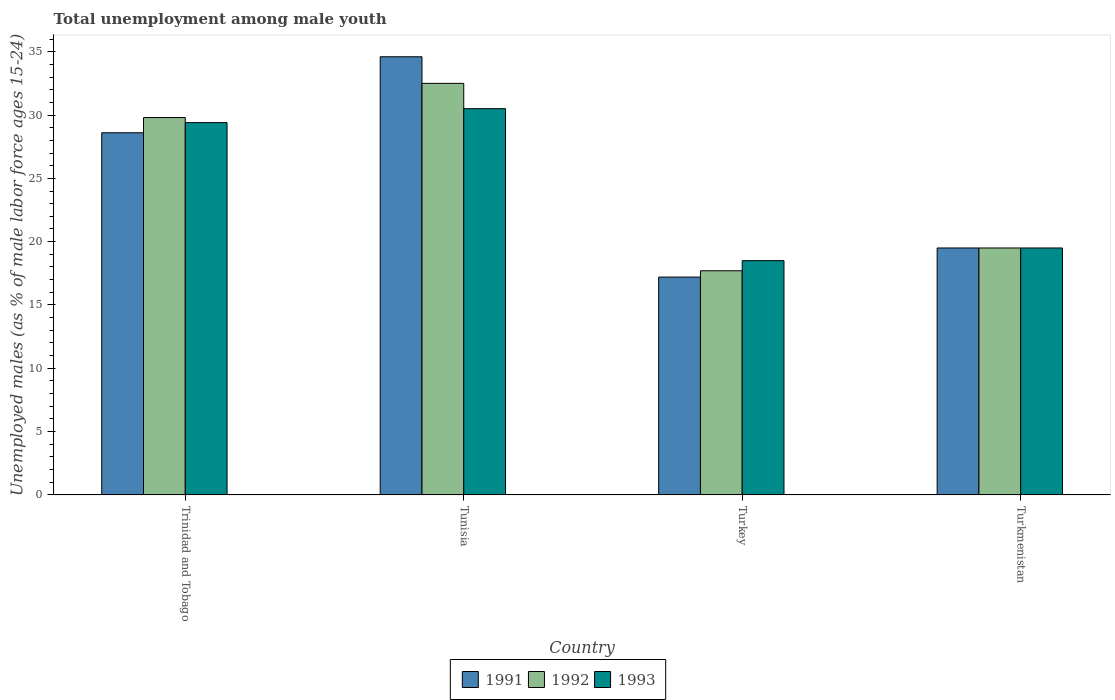How many different coloured bars are there?
Your answer should be very brief. 3. How many groups of bars are there?
Provide a short and direct response. 4. What is the label of the 2nd group of bars from the left?
Your answer should be compact. Tunisia. In how many cases, is the number of bars for a given country not equal to the number of legend labels?
Provide a short and direct response. 0. What is the percentage of unemployed males in in 1991 in Tunisia?
Provide a short and direct response. 34.6. Across all countries, what is the maximum percentage of unemployed males in in 1992?
Your response must be concise. 32.5. Across all countries, what is the minimum percentage of unemployed males in in 1992?
Your answer should be compact. 17.7. In which country was the percentage of unemployed males in in 1991 maximum?
Make the answer very short. Tunisia. In which country was the percentage of unemployed males in in 1993 minimum?
Make the answer very short. Turkey. What is the total percentage of unemployed males in in 1993 in the graph?
Your response must be concise. 97.9. What is the difference between the percentage of unemployed males in in 1993 in Trinidad and Tobago and that in Turkmenistan?
Offer a terse response. 9.9. What is the difference between the percentage of unemployed males in in 1991 in Turkmenistan and the percentage of unemployed males in in 1992 in Trinidad and Tobago?
Ensure brevity in your answer.  -10.3. What is the average percentage of unemployed males in in 1993 per country?
Your answer should be very brief. 24.47. What is the difference between the percentage of unemployed males in of/in 1991 and percentage of unemployed males in of/in 1992 in Tunisia?
Your answer should be compact. 2.1. What is the ratio of the percentage of unemployed males in in 1992 in Turkey to that in Turkmenistan?
Give a very brief answer. 0.91. Is the percentage of unemployed males in in 1991 in Turkey less than that in Turkmenistan?
Keep it short and to the point. Yes. What is the difference between the highest and the lowest percentage of unemployed males in in 1993?
Ensure brevity in your answer.  12. Is the sum of the percentage of unemployed males in in 1991 in Trinidad and Tobago and Turkey greater than the maximum percentage of unemployed males in in 1992 across all countries?
Provide a short and direct response. Yes. Is it the case that in every country, the sum of the percentage of unemployed males in in 1993 and percentage of unemployed males in in 1991 is greater than the percentage of unemployed males in in 1992?
Provide a succinct answer. Yes. How many bars are there?
Offer a very short reply. 12. How many countries are there in the graph?
Offer a terse response. 4. What is the difference between two consecutive major ticks on the Y-axis?
Offer a terse response. 5. Does the graph contain any zero values?
Ensure brevity in your answer.  No. What is the title of the graph?
Offer a very short reply. Total unemployment among male youth. Does "1983" appear as one of the legend labels in the graph?
Make the answer very short. No. What is the label or title of the Y-axis?
Keep it short and to the point. Unemployed males (as % of male labor force ages 15-24). What is the Unemployed males (as % of male labor force ages 15-24) in 1991 in Trinidad and Tobago?
Provide a succinct answer. 28.6. What is the Unemployed males (as % of male labor force ages 15-24) of 1992 in Trinidad and Tobago?
Provide a short and direct response. 29.8. What is the Unemployed males (as % of male labor force ages 15-24) of 1993 in Trinidad and Tobago?
Make the answer very short. 29.4. What is the Unemployed males (as % of male labor force ages 15-24) in 1991 in Tunisia?
Provide a succinct answer. 34.6. What is the Unemployed males (as % of male labor force ages 15-24) in 1992 in Tunisia?
Provide a short and direct response. 32.5. What is the Unemployed males (as % of male labor force ages 15-24) in 1993 in Tunisia?
Make the answer very short. 30.5. What is the Unemployed males (as % of male labor force ages 15-24) in 1991 in Turkey?
Keep it short and to the point. 17.2. What is the Unemployed males (as % of male labor force ages 15-24) in 1992 in Turkey?
Make the answer very short. 17.7. What is the Unemployed males (as % of male labor force ages 15-24) of 1993 in Turkey?
Keep it short and to the point. 18.5. What is the Unemployed males (as % of male labor force ages 15-24) of 1992 in Turkmenistan?
Ensure brevity in your answer.  19.5. Across all countries, what is the maximum Unemployed males (as % of male labor force ages 15-24) of 1991?
Provide a short and direct response. 34.6. Across all countries, what is the maximum Unemployed males (as % of male labor force ages 15-24) in 1992?
Keep it short and to the point. 32.5. Across all countries, what is the maximum Unemployed males (as % of male labor force ages 15-24) in 1993?
Give a very brief answer. 30.5. Across all countries, what is the minimum Unemployed males (as % of male labor force ages 15-24) of 1991?
Offer a terse response. 17.2. Across all countries, what is the minimum Unemployed males (as % of male labor force ages 15-24) in 1992?
Offer a terse response. 17.7. Across all countries, what is the minimum Unemployed males (as % of male labor force ages 15-24) of 1993?
Ensure brevity in your answer.  18.5. What is the total Unemployed males (as % of male labor force ages 15-24) of 1991 in the graph?
Ensure brevity in your answer.  99.9. What is the total Unemployed males (as % of male labor force ages 15-24) of 1992 in the graph?
Ensure brevity in your answer.  99.5. What is the total Unemployed males (as % of male labor force ages 15-24) in 1993 in the graph?
Offer a very short reply. 97.9. What is the difference between the Unemployed males (as % of male labor force ages 15-24) in 1991 in Trinidad and Tobago and that in Tunisia?
Offer a terse response. -6. What is the difference between the Unemployed males (as % of male labor force ages 15-24) in 1991 in Trinidad and Tobago and that in Turkey?
Give a very brief answer. 11.4. What is the difference between the Unemployed males (as % of male labor force ages 15-24) in 1992 in Trinidad and Tobago and that in Turkey?
Keep it short and to the point. 12.1. What is the difference between the Unemployed males (as % of male labor force ages 15-24) in 1993 in Trinidad and Tobago and that in Turkey?
Keep it short and to the point. 10.9. What is the difference between the Unemployed males (as % of male labor force ages 15-24) in 1991 in Trinidad and Tobago and that in Turkmenistan?
Make the answer very short. 9.1. What is the difference between the Unemployed males (as % of male labor force ages 15-24) in 1993 in Trinidad and Tobago and that in Turkmenistan?
Provide a succinct answer. 9.9. What is the difference between the Unemployed males (as % of male labor force ages 15-24) of 1992 in Tunisia and that in Turkmenistan?
Your answer should be compact. 13. What is the difference between the Unemployed males (as % of male labor force ages 15-24) of 1991 in Trinidad and Tobago and the Unemployed males (as % of male labor force ages 15-24) of 1992 in Tunisia?
Your answer should be compact. -3.9. What is the difference between the Unemployed males (as % of male labor force ages 15-24) in 1991 in Trinidad and Tobago and the Unemployed males (as % of male labor force ages 15-24) in 1993 in Tunisia?
Provide a short and direct response. -1.9. What is the difference between the Unemployed males (as % of male labor force ages 15-24) of 1991 in Trinidad and Tobago and the Unemployed males (as % of male labor force ages 15-24) of 1992 in Turkey?
Make the answer very short. 10.9. What is the difference between the Unemployed males (as % of male labor force ages 15-24) of 1991 in Trinidad and Tobago and the Unemployed males (as % of male labor force ages 15-24) of 1993 in Turkey?
Give a very brief answer. 10.1. What is the difference between the Unemployed males (as % of male labor force ages 15-24) of 1992 in Trinidad and Tobago and the Unemployed males (as % of male labor force ages 15-24) of 1993 in Turkmenistan?
Offer a terse response. 10.3. What is the difference between the Unemployed males (as % of male labor force ages 15-24) in 1991 in Tunisia and the Unemployed males (as % of male labor force ages 15-24) in 1992 in Turkey?
Provide a short and direct response. 16.9. What is the difference between the Unemployed males (as % of male labor force ages 15-24) in 1992 in Tunisia and the Unemployed males (as % of male labor force ages 15-24) in 1993 in Turkey?
Provide a succinct answer. 14. What is the difference between the Unemployed males (as % of male labor force ages 15-24) in 1991 in Tunisia and the Unemployed males (as % of male labor force ages 15-24) in 1993 in Turkmenistan?
Provide a succinct answer. 15.1. What is the difference between the Unemployed males (as % of male labor force ages 15-24) of 1992 in Tunisia and the Unemployed males (as % of male labor force ages 15-24) of 1993 in Turkmenistan?
Make the answer very short. 13. What is the difference between the Unemployed males (as % of male labor force ages 15-24) of 1991 in Turkey and the Unemployed males (as % of male labor force ages 15-24) of 1993 in Turkmenistan?
Keep it short and to the point. -2.3. What is the average Unemployed males (as % of male labor force ages 15-24) of 1991 per country?
Your answer should be compact. 24.98. What is the average Unemployed males (as % of male labor force ages 15-24) of 1992 per country?
Make the answer very short. 24.88. What is the average Unemployed males (as % of male labor force ages 15-24) of 1993 per country?
Offer a very short reply. 24.48. What is the difference between the Unemployed males (as % of male labor force ages 15-24) in 1992 and Unemployed males (as % of male labor force ages 15-24) in 1993 in Trinidad and Tobago?
Keep it short and to the point. 0.4. What is the difference between the Unemployed males (as % of male labor force ages 15-24) of 1991 and Unemployed males (as % of male labor force ages 15-24) of 1992 in Tunisia?
Provide a short and direct response. 2.1. What is the difference between the Unemployed males (as % of male labor force ages 15-24) in 1992 and Unemployed males (as % of male labor force ages 15-24) in 1993 in Turkmenistan?
Keep it short and to the point. 0. What is the ratio of the Unemployed males (as % of male labor force ages 15-24) in 1991 in Trinidad and Tobago to that in Tunisia?
Your answer should be very brief. 0.83. What is the ratio of the Unemployed males (as % of male labor force ages 15-24) of 1992 in Trinidad and Tobago to that in Tunisia?
Offer a very short reply. 0.92. What is the ratio of the Unemployed males (as % of male labor force ages 15-24) in 1993 in Trinidad and Tobago to that in Tunisia?
Your response must be concise. 0.96. What is the ratio of the Unemployed males (as % of male labor force ages 15-24) of 1991 in Trinidad and Tobago to that in Turkey?
Make the answer very short. 1.66. What is the ratio of the Unemployed males (as % of male labor force ages 15-24) in 1992 in Trinidad and Tobago to that in Turkey?
Make the answer very short. 1.68. What is the ratio of the Unemployed males (as % of male labor force ages 15-24) in 1993 in Trinidad and Tobago to that in Turkey?
Make the answer very short. 1.59. What is the ratio of the Unemployed males (as % of male labor force ages 15-24) of 1991 in Trinidad and Tobago to that in Turkmenistan?
Give a very brief answer. 1.47. What is the ratio of the Unemployed males (as % of male labor force ages 15-24) in 1992 in Trinidad and Tobago to that in Turkmenistan?
Your answer should be very brief. 1.53. What is the ratio of the Unemployed males (as % of male labor force ages 15-24) of 1993 in Trinidad and Tobago to that in Turkmenistan?
Your response must be concise. 1.51. What is the ratio of the Unemployed males (as % of male labor force ages 15-24) in 1991 in Tunisia to that in Turkey?
Your answer should be compact. 2.01. What is the ratio of the Unemployed males (as % of male labor force ages 15-24) in 1992 in Tunisia to that in Turkey?
Offer a terse response. 1.84. What is the ratio of the Unemployed males (as % of male labor force ages 15-24) of 1993 in Tunisia to that in Turkey?
Your response must be concise. 1.65. What is the ratio of the Unemployed males (as % of male labor force ages 15-24) of 1991 in Tunisia to that in Turkmenistan?
Give a very brief answer. 1.77. What is the ratio of the Unemployed males (as % of male labor force ages 15-24) of 1992 in Tunisia to that in Turkmenistan?
Make the answer very short. 1.67. What is the ratio of the Unemployed males (as % of male labor force ages 15-24) in 1993 in Tunisia to that in Turkmenistan?
Ensure brevity in your answer.  1.56. What is the ratio of the Unemployed males (as % of male labor force ages 15-24) of 1991 in Turkey to that in Turkmenistan?
Make the answer very short. 0.88. What is the ratio of the Unemployed males (as % of male labor force ages 15-24) in 1992 in Turkey to that in Turkmenistan?
Offer a terse response. 0.91. What is the ratio of the Unemployed males (as % of male labor force ages 15-24) in 1993 in Turkey to that in Turkmenistan?
Your answer should be compact. 0.95. What is the difference between the highest and the second highest Unemployed males (as % of male labor force ages 15-24) in 1992?
Keep it short and to the point. 2.7. 